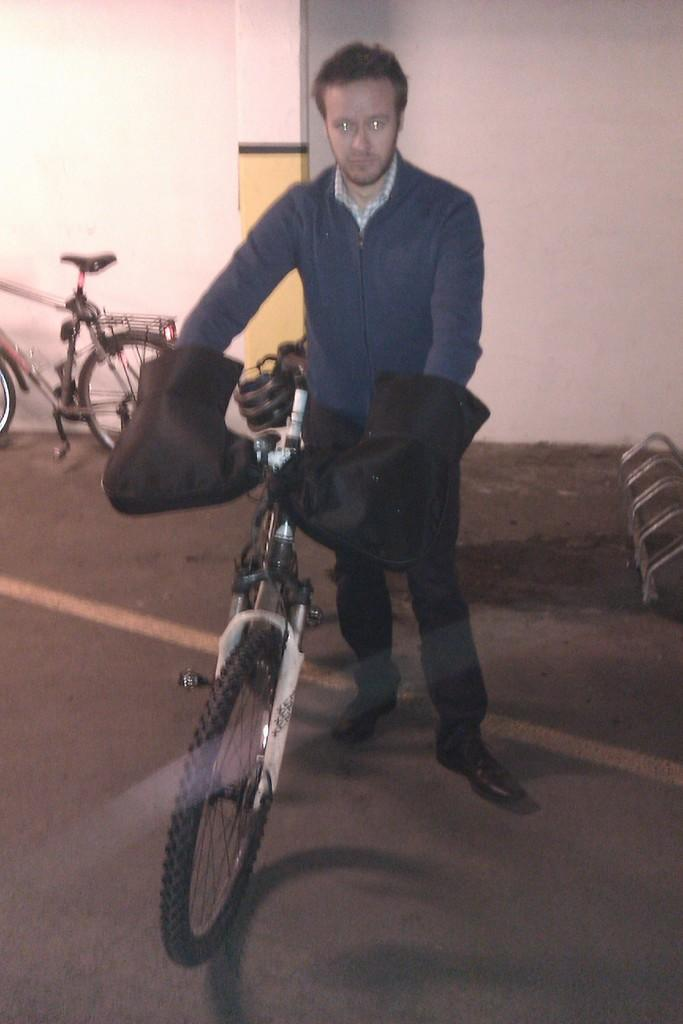What is the man in the image doing? The man is standing in the image and holding the handles of a bicycle. Can you describe the bicycles in the image? There are two bicycles in the image, and both are on stands. What is visible in the background of the image? There is a white wall in the background of the image. What type of army is depicted in the image? There is no army present in the image; it features a man standing with bicycles and a white wall in the background. What is the sun doing in the image? The sun is not visible in the image; it only shows a man, bicycles, and a white wall. 